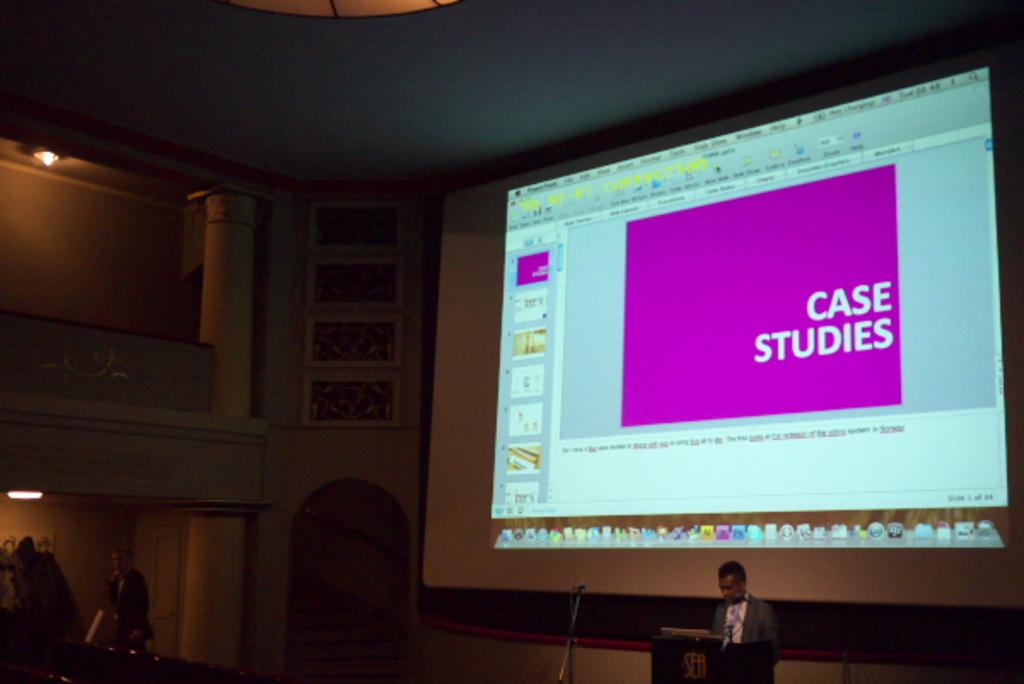What kind of studies?
Give a very brief answer. Case. 